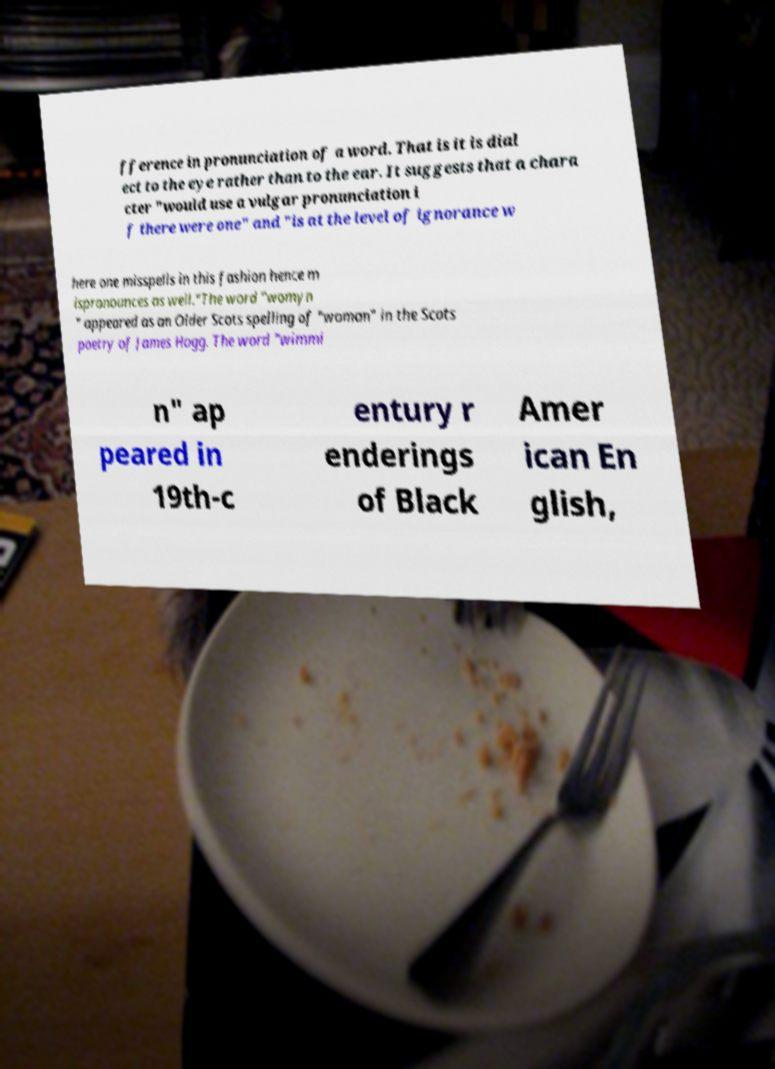I need the written content from this picture converted into text. Can you do that? fference in pronunciation of a word. That is it is dial ect to the eye rather than to the ear. It suggests that a chara cter "would use a vulgar pronunciation i f there were one" and "is at the level of ignorance w here one misspells in this fashion hence m ispronounces as well."The word "womyn " appeared as an Older Scots spelling of "woman" in the Scots poetry of James Hogg. The word "wimmi n" ap peared in 19th-c entury r enderings of Black Amer ican En glish, 